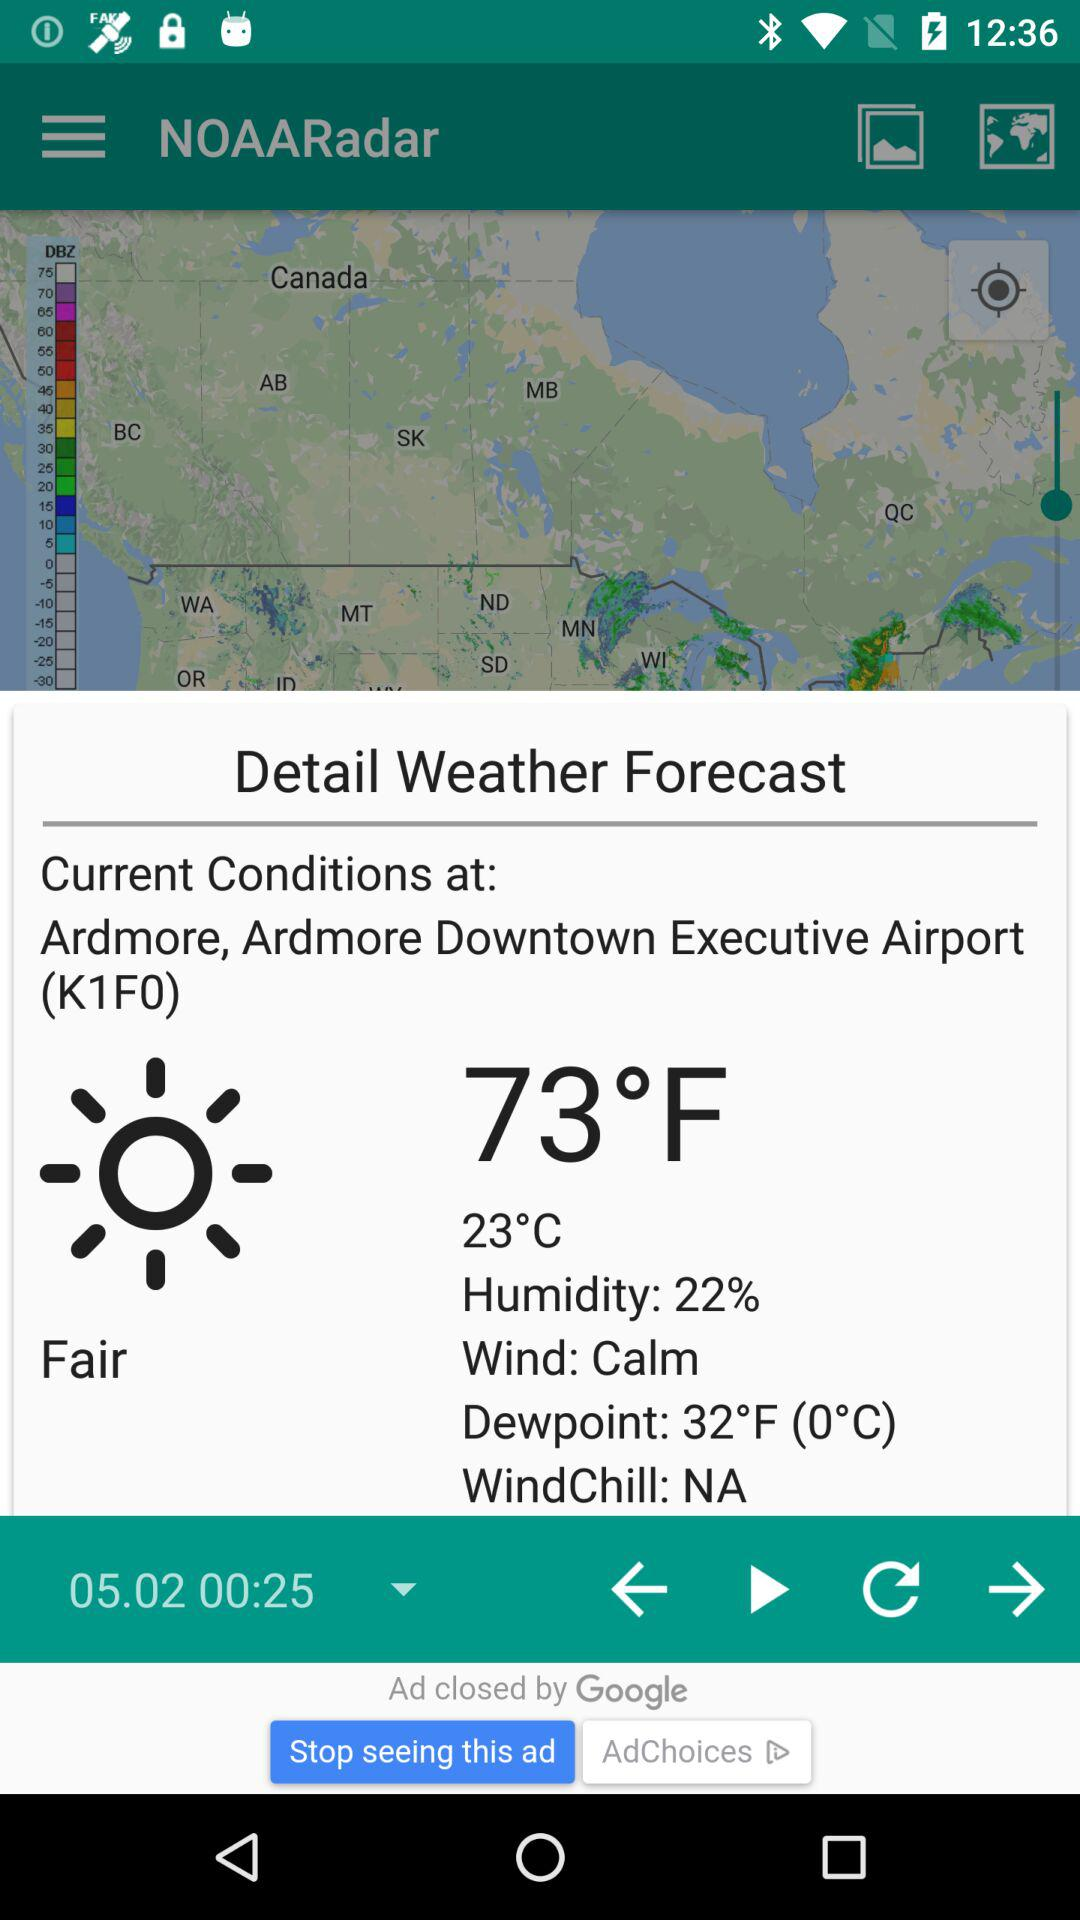What is the percentage of humidity? The humidity is 22%. 